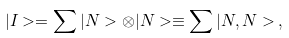Convert formula to latex. <formula><loc_0><loc_0><loc_500><loc_500>| I > = \sum | N > \otimes | N > \equiv \sum | N , N > \, ,</formula> 